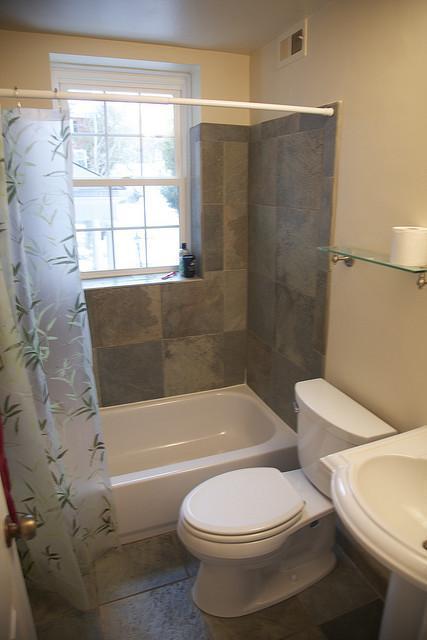How many zebras are facing the camera?
Give a very brief answer. 0. 